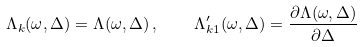<formula> <loc_0><loc_0><loc_500><loc_500>\Lambda _ { k } ( \omega , \Delta ) = \Lambda ( \omega , \Delta ) \, , \quad \Lambda ^ { \prime } _ { k 1 } ( \omega , \Delta ) = \frac { \partial \Lambda ( \omega , \Delta ) } { \partial \Delta }</formula> 